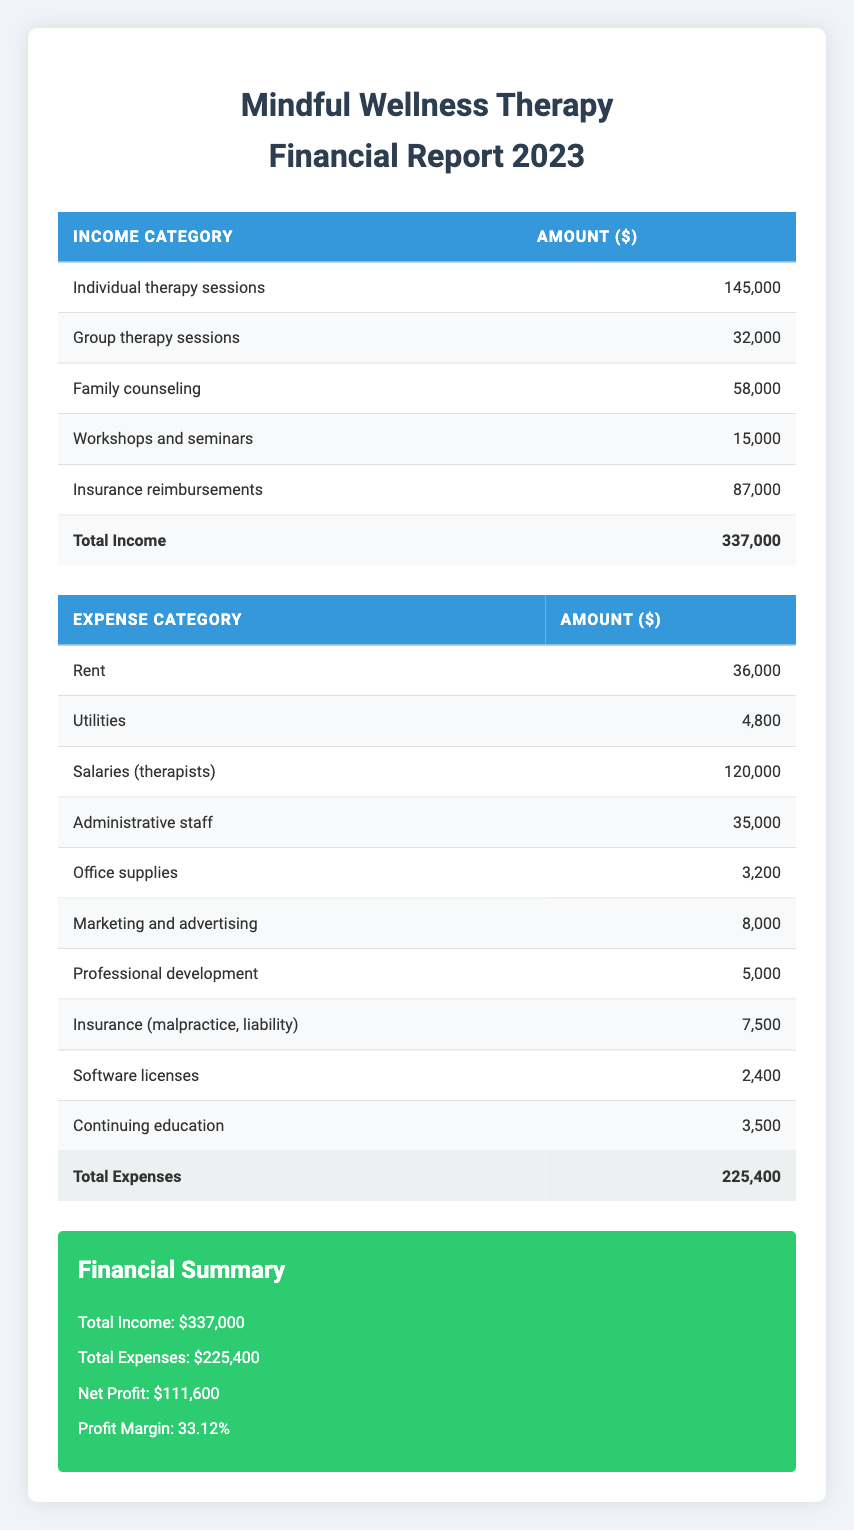What is the total income for Mindful Wellness Therapy in 2023? The total income is provided in the financial summary section of the table. It states that total income is $337,000.
Answer: 337000 What are the expenses for Administrative staff? The table includes a specific expense category for Administrative staff, and their expense amount is listed as $35,000.
Answer: 35000 Is the net profit more than $100,000? The financial summary indicates that the net profit is $111,600, which is greater than $100,000. Therefore, the statement is true.
Answer: Yes What is the total amount spent on utilities and office supplies together? To find this, we need to sum the individual amounts of utilities ($4,800) and office supplies ($3,200). Adding these gives $4,800 + $3,200 = $8,000.
Answer: 8000 What percentage of total income is generated from individual therapy sessions? Individual therapy sessions generate $145,000. To calculate the percentage of total income, divide $145,000 by the total income ($337,000) and multiply by 100. Thus, ($145,000 / $337,000) * 100 = 43.0%.
Answer: 43.0% What is the difference between total income and total expenses? The total income is $337,000, and total expenses are $225,400. The difference can be found by subtracting total expenses from total income: $337,000 - $225,400 = $111,600.
Answer: 111600 Are the total expenses greater than the total income? The total expenses amount to $225,400, and the total income is $337,000. Since $225,400 is less than $337,000, the statement is false.
Answer: No What is the overall profit margin for the practice? The profit margin is provided in the financial summary. It is stated that the profit margin is 33.12%, which represents net profit as a percentage of total income.
Answer: 33.12% 